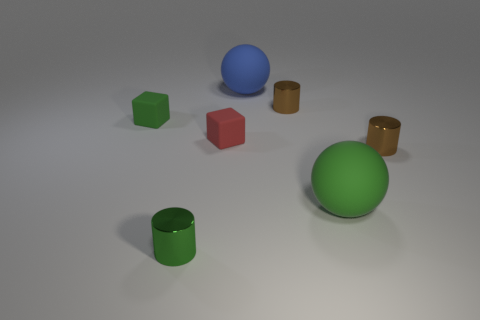There is another cube that is the same size as the green cube; what is its color?
Offer a very short reply. Red. What number of big things are blue rubber balls or purple rubber things?
Make the answer very short. 1. There is a object that is behind the red matte cube and to the left of the big blue rubber sphere; what is it made of?
Give a very brief answer. Rubber. Does the big rubber object that is in front of the blue ball have the same shape as the tiny rubber thing behind the tiny red matte object?
Your answer should be very brief. No. What number of objects are small red cubes that are to the right of the green block or large gray cubes?
Your answer should be compact. 1. Is the size of the green rubber sphere the same as the blue matte thing?
Make the answer very short. Yes. The big matte ball that is behind the red rubber thing is what color?
Keep it short and to the point. Blue. The red thing that is made of the same material as the big blue sphere is what size?
Provide a succinct answer. Small. Do the red object and the shiny thing behind the tiny red object have the same size?
Ensure brevity in your answer.  Yes. What material is the block behind the small red matte thing?
Your answer should be compact. Rubber. 